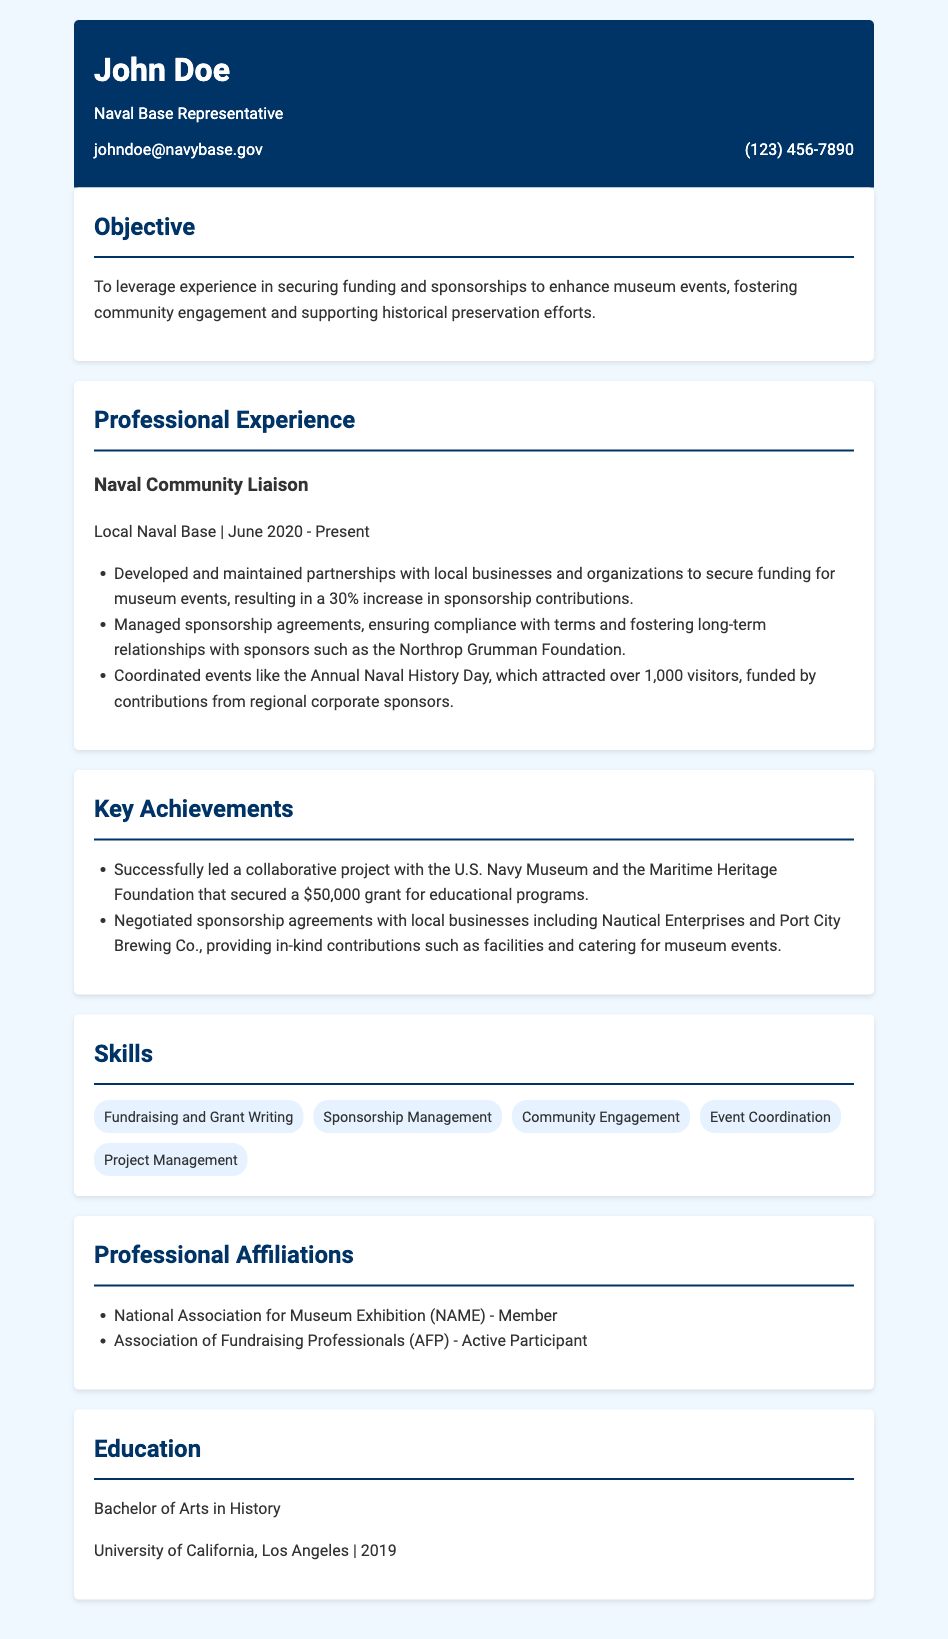What is John Doe's job title? The job title is mentioned in the header section of the resume.
Answer: Naval Base Representative When did John Doe start his position at the local Naval Base? The start date of the position is listed under the job experience section.
Answer: June 2020 What percentage increase in sponsorship contributions did John Doe achieve? The percentage increase in sponsorship contributions is specified in the professional experience section.
Answer: 30% How much funding did John Doe secure for educational programs? The amount is noted in the key achievements section of the resume.
Answer: $50,000 Which organization provided a grant for educational programs? The organization that provided the grant is mentioned in the key achievements section.
Answer: U.S. Navy Museum Name one local business John Doe negotiated a sponsorship agreement with. The names of businesses are listed in the key achievements section.
Answer: Nautical Enterprises What degree did John Doe earn, and from which university? The education section specifies the degree and the institution.
Answer: Bachelor of Arts in History, University of California, Los Angeles What is one of John Doe's skills? The skills section lists various skills possessed by John Doe.
Answer: Fundraising and Grant Writing 